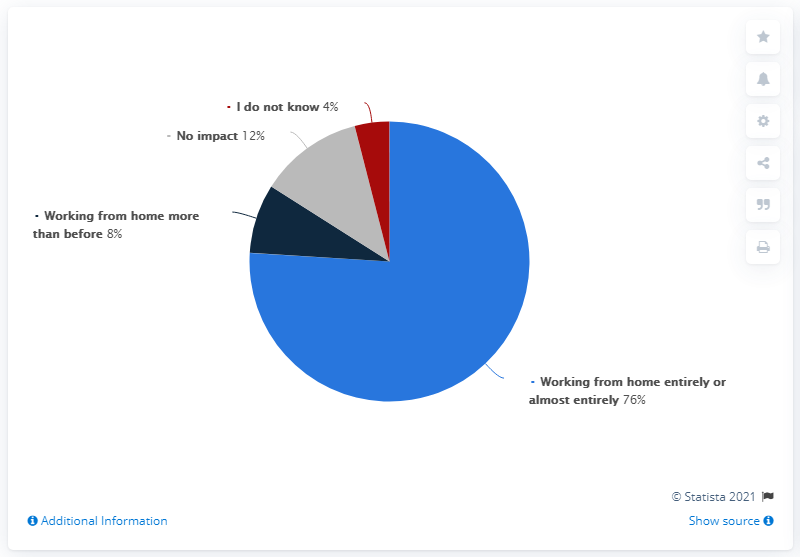Draw attention to some important aspects in this diagram. According to the survey, 12% of respondents reported that they were working from home more frequently than before. 